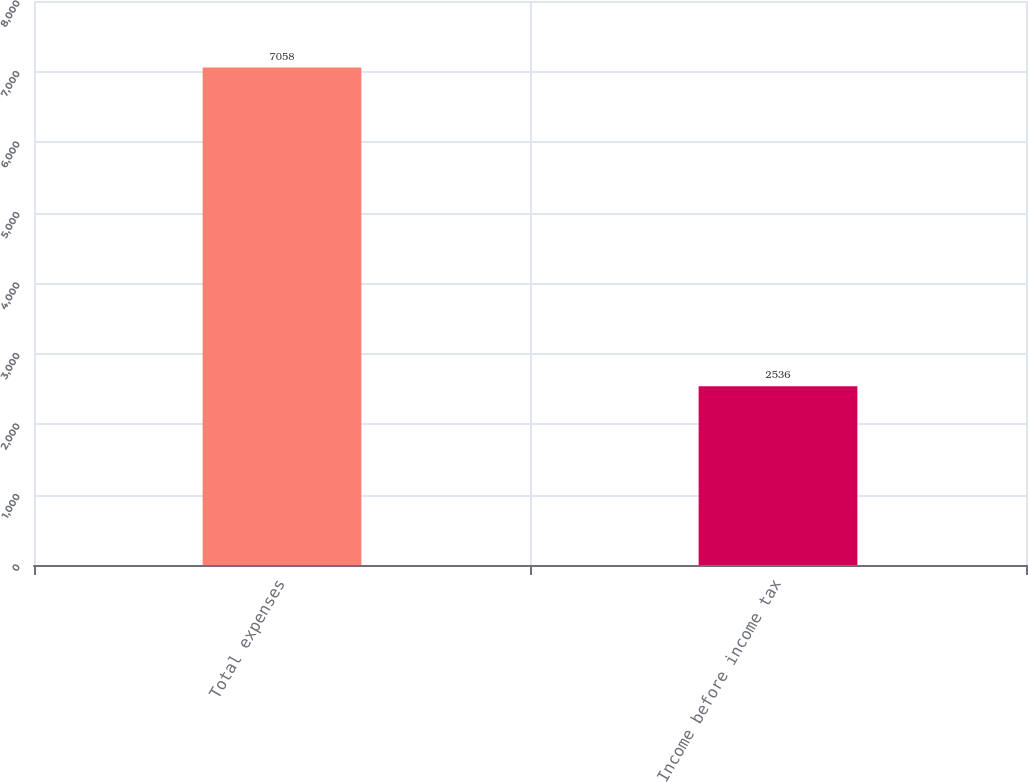Convert chart. <chart><loc_0><loc_0><loc_500><loc_500><bar_chart><fcel>Total expenses<fcel>Income before income tax<nl><fcel>7058<fcel>2536<nl></chart> 